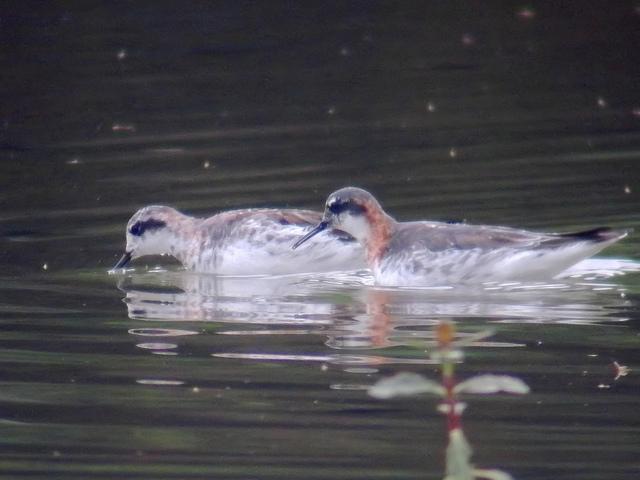Are these the same species of bird?
Quick response, please. Yes. What animals are these?
Keep it brief. Ducks. Are the ducks eating?
Quick response, please. Yes. Are the birds in flight?
Concise answer only. No. 